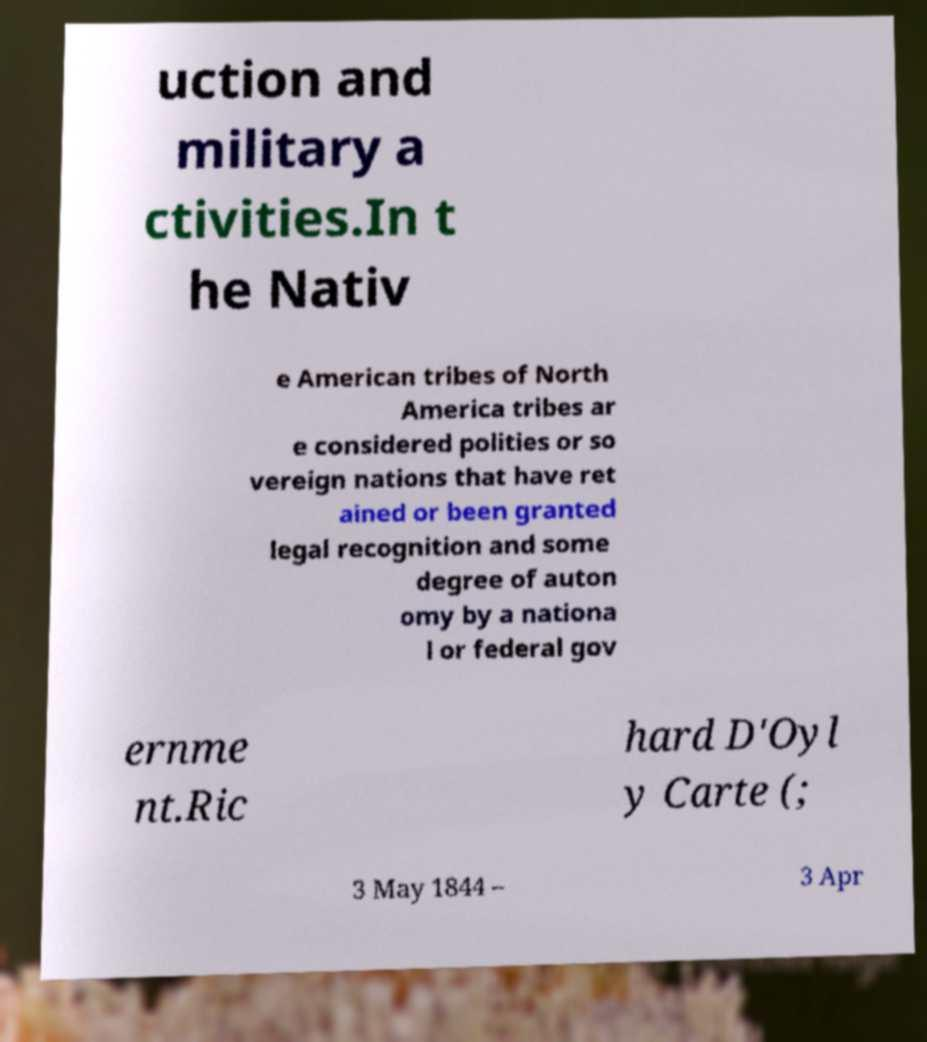I need the written content from this picture converted into text. Can you do that? uction and military a ctivities.In t he Nativ e American tribes of North America tribes ar e considered polities or so vereign nations that have ret ained or been granted legal recognition and some degree of auton omy by a nationa l or federal gov ernme nt.Ric hard D'Oyl y Carte (; 3 May 1844 – 3 Apr 